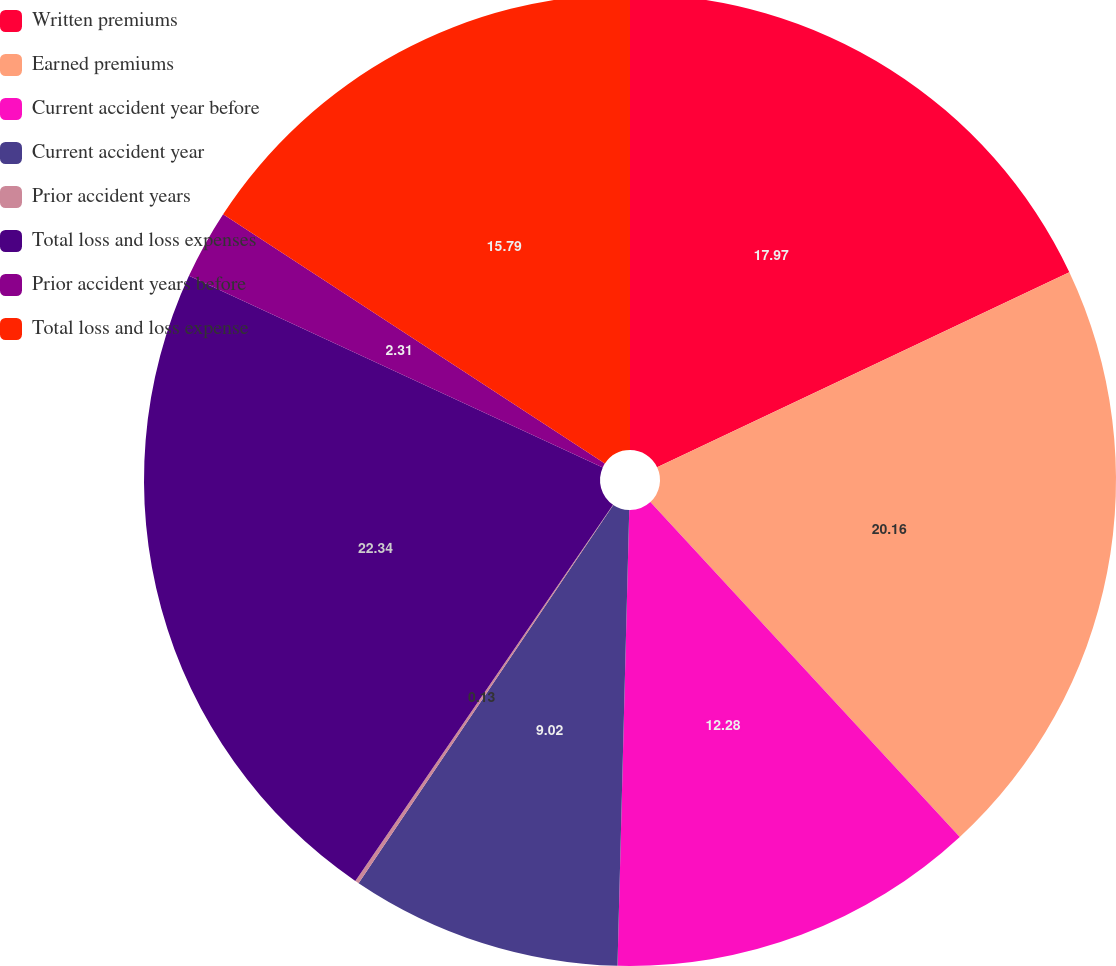<chart> <loc_0><loc_0><loc_500><loc_500><pie_chart><fcel>Written premiums<fcel>Earned premiums<fcel>Current accident year before<fcel>Current accident year<fcel>Prior accident years<fcel>Total loss and loss expenses<fcel>Prior accident years before<fcel>Total loss and loss expense<nl><fcel>17.97%<fcel>20.16%<fcel>12.28%<fcel>9.02%<fcel>0.13%<fcel>22.34%<fcel>2.31%<fcel>15.79%<nl></chart> 